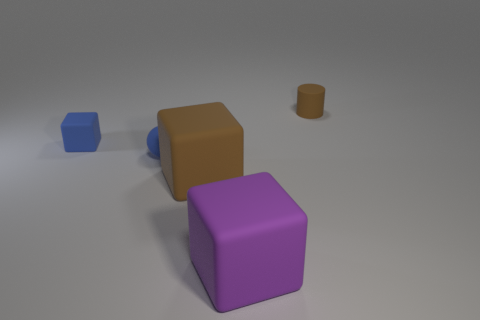Add 1 large cyan cylinders. How many objects exist? 6 Subtract all cubes. How many objects are left? 2 Subtract all tiny blocks. Subtract all small red matte objects. How many objects are left? 4 Add 1 tiny blue matte cubes. How many tiny blue matte cubes are left? 2 Add 1 cubes. How many cubes exist? 4 Subtract 1 blue cubes. How many objects are left? 4 